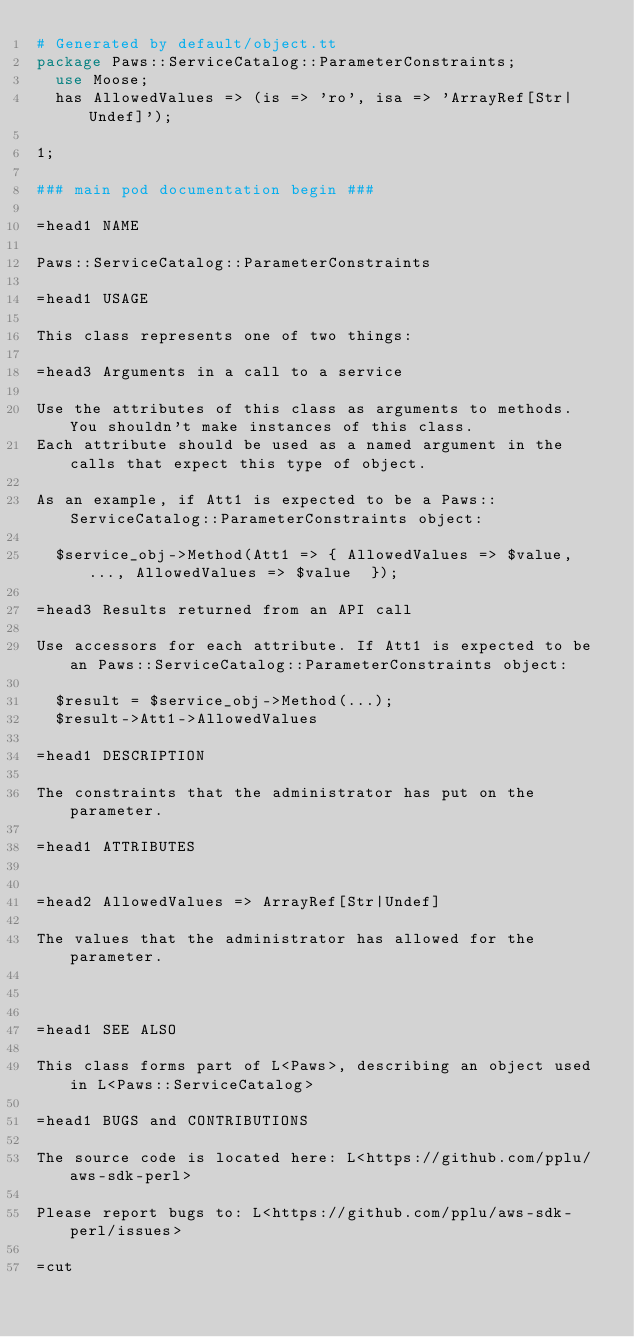<code> <loc_0><loc_0><loc_500><loc_500><_Perl_># Generated by default/object.tt
package Paws::ServiceCatalog::ParameterConstraints;
  use Moose;
  has AllowedValues => (is => 'ro', isa => 'ArrayRef[Str|Undef]');

1;

### main pod documentation begin ###

=head1 NAME

Paws::ServiceCatalog::ParameterConstraints

=head1 USAGE

This class represents one of two things:

=head3 Arguments in a call to a service

Use the attributes of this class as arguments to methods. You shouldn't make instances of this class. 
Each attribute should be used as a named argument in the calls that expect this type of object.

As an example, if Att1 is expected to be a Paws::ServiceCatalog::ParameterConstraints object:

  $service_obj->Method(Att1 => { AllowedValues => $value, ..., AllowedValues => $value  });

=head3 Results returned from an API call

Use accessors for each attribute. If Att1 is expected to be an Paws::ServiceCatalog::ParameterConstraints object:

  $result = $service_obj->Method(...);
  $result->Att1->AllowedValues

=head1 DESCRIPTION

The constraints that the administrator has put on the parameter.

=head1 ATTRIBUTES


=head2 AllowedValues => ArrayRef[Str|Undef]

The values that the administrator has allowed for the parameter.



=head1 SEE ALSO

This class forms part of L<Paws>, describing an object used in L<Paws::ServiceCatalog>

=head1 BUGS and CONTRIBUTIONS

The source code is located here: L<https://github.com/pplu/aws-sdk-perl>

Please report bugs to: L<https://github.com/pplu/aws-sdk-perl/issues>

=cut

</code> 